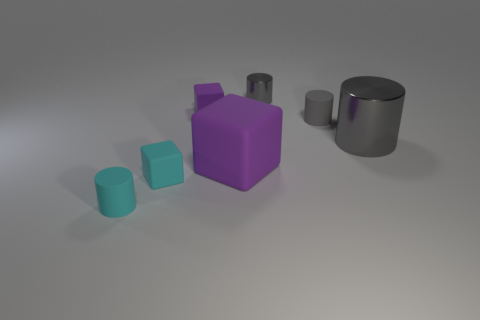What shape is the small purple object that is the same material as the cyan cylinder?
Make the answer very short. Cube. Is the size of the shiny object that is in front of the small metal object the same as the cylinder on the left side of the tiny gray metal thing?
Provide a succinct answer. No. What is the color of the tiny matte cylinder behind the cyan matte cylinder?
Ensure brevity in your answer.  Gray. There is a purple block that is in front of the gray metallic object right of the tiny metallic cylinder; what is it made of?
Your response must be concise. Rubber. The gray matte thing is what shape?
Provide a succinct answer. Cylinder. What is the material of the tiny cyan object that is the same shape as the tiny purple matte object?
Your answer should be compact. Rubber. What number of cyan things have the same size as the gray rubber thing?
Offer a terse response. 2. There is a small rubber cylinder that is behind the large gray thing; are there any blocks behind it?
Make the answer very short. Yes. How many brown objects are either tiny shiny objects or tiny things?
Your answer should be compact. 0. The big rubber thing has what color?
Offer a very short reply. Purple. 